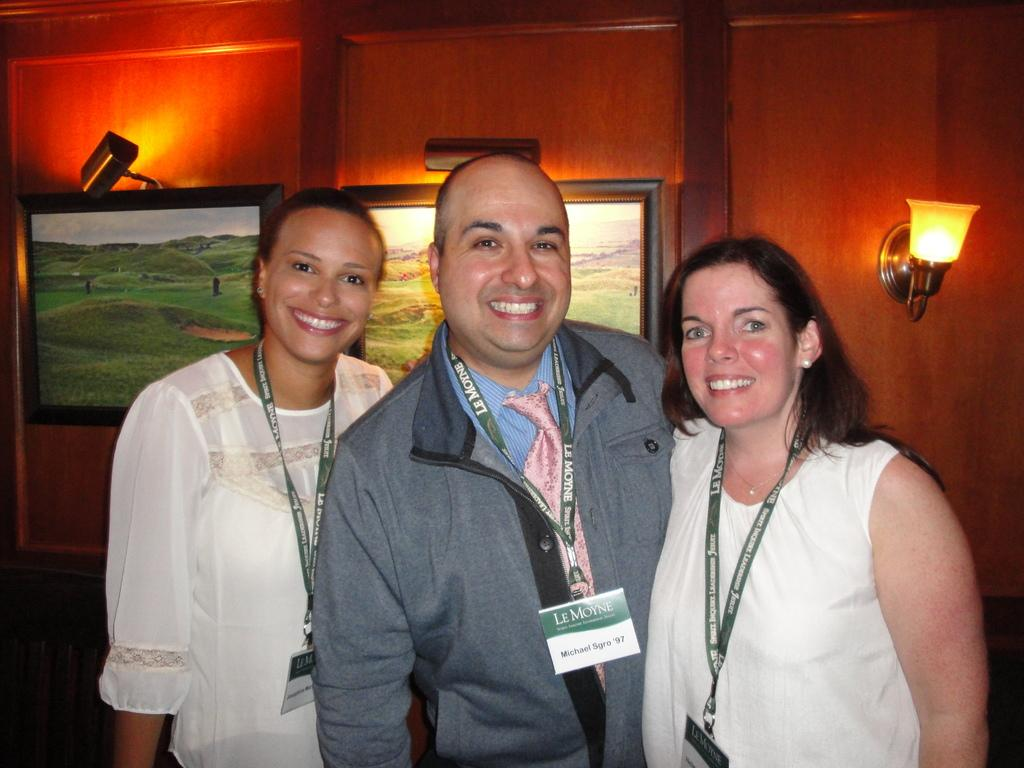How many people are present in the image? There are three people in the image. What are the people wearing? The people are wearing clothes. What can be seen on the wall in the image? There are photo frames on the wall. Where is the light located in the image? The light is on the right side of the image. How many deer can be seen in the image? There are no deer present in the image. What type of iron is being used by the people in the image? There is no iron visible in the image, and the people are not using any iron. 